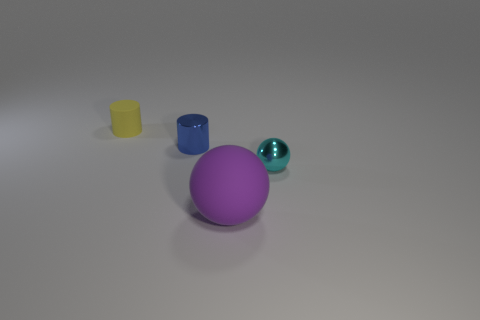What number of large things are purple things or blue metallic cylinders?
Offer a very short reply. 1. There is a ball that is the same material as the blue thing; what color is it?
Offer a terse response. Cyan. How many large things are the same material as the tiny ball?
Offer a terse response. 0. There is a matte cylinder that is behind the small cyan shiny thing; is its size the same as the sphere behind the purple matte ball?
Your response must be concise. Yes. What is the material of the ball that is in front of the sphere behind the purple matte ball?
Provide a short and direct response. Rubber. Is the number of purple rubber things behind the blue metal cylinder less than the number of small metallic cylinders on the left side of the tiny cyan thing?
Keep it short and to the point. Yes. Is there anything else that is the same shape as the cyan object?
Your answer should be very brief. Yes. What is the blue object on the right side of the tiny yellow matte object made of?
Your response must be concise. Metal. Are there any other things that have the same size as the purple matte sphere?
Provide a short and direct response. No. There is a large purple object; are there any tiny yellow cylinders left of it?
Ensure brevity in your answer.  Yes. 